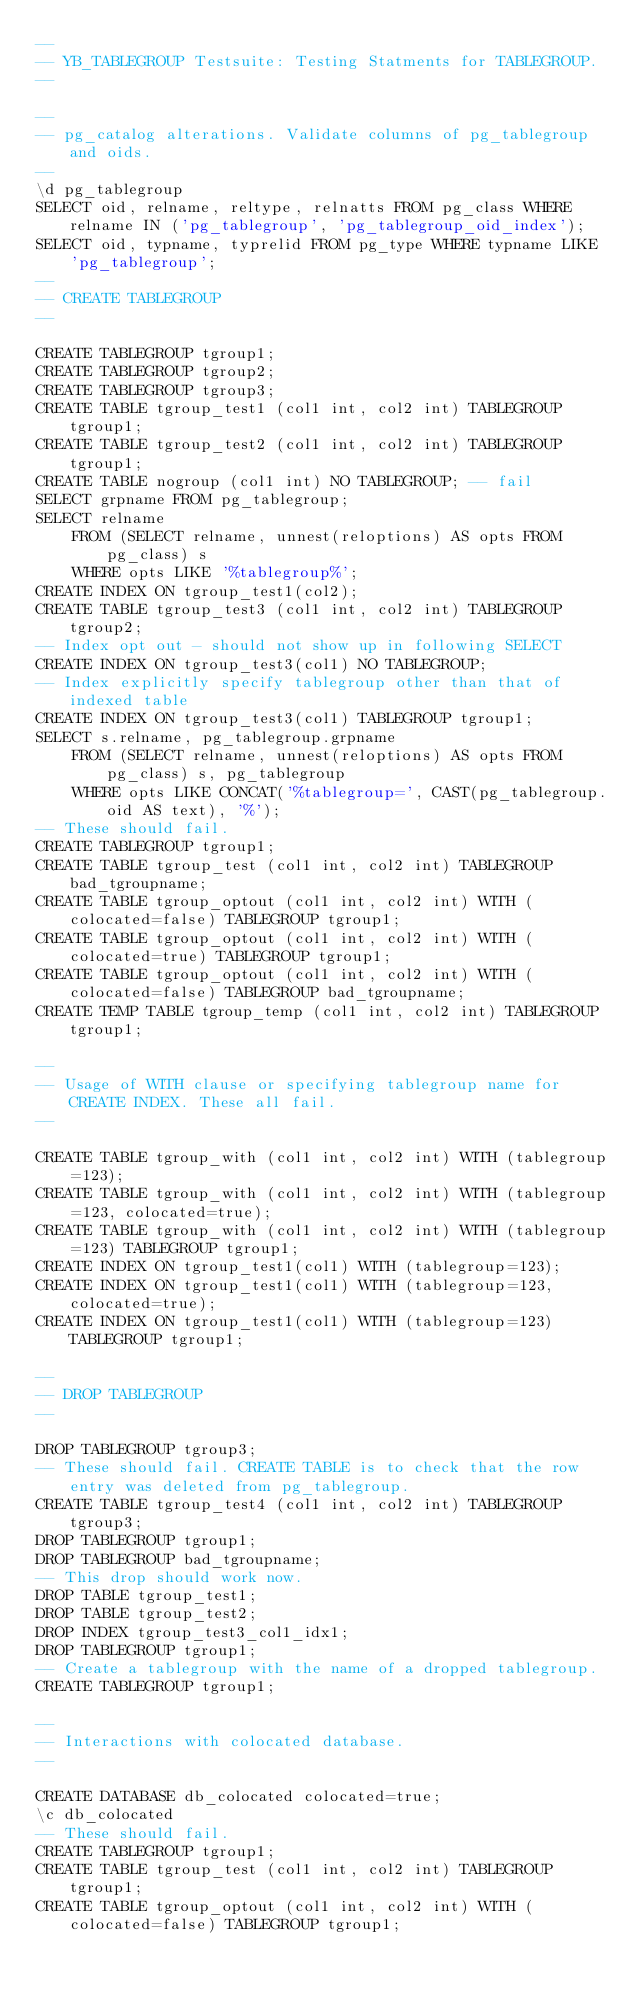Convert code to text. <code><loc_0><loc_0><loc_500><loc_500><_SQL_>--
-- YB_TABLEGROUP Testsuite: Testing Statments for TABLEGROUP.
--

--
-- pg_catalog alterations. Validate columns of pg_tablegroup and oids.
--
\d pg_tablegroup
SELECT oid, relname, reltype, relnatts FROM pg_class WHERE relname IN ('pg_tablegroup', 'pg_tablegroup_oid_index');
SELECT oid, typname, typrelid FROM pg_type WHERE typname LIKE 'pg_tablegroup';
--
-- CREATE TABLEGROUP
--

CREATE TABLEGROUP tgroup1;
CREATE TABLEGROUP tgroup2;
CREATE TABLEGROUP tgroup3;
CREATE TABLE tgroup_test1 (col1 int, col2 int) TABLEGROUP tgroup1;
CREATE TABLE tgroup_test2 (col1 int, col2 int) TABLEGROUP tgroup1;
CREATE TABLE nogroup (col1 int) NO TABLEGROUP; -- fail
SELECT grpname FROM pg_tablegroup;
SELECT relname
    FROM (SELECT relname, unnest(reloptions) AS opts FROM pg_class) s
    WHERE opts LIKE '%tablegroup%';
CREATE INDEX ON tgroup_test1(col2);
CREATE TABLE tgroup_test3 (col1 int, col2 int) TABLEGROUP tgroup2;
-- Index opt out - should not show up in following SELECT
CREATE INDEX ON tgroup_test3(col1) NO TABLEGROUP;
-- Index explicitly specify tablegroup other than that of indexed table
CREATE INDEX ON tgroup_test3(col1) TABLEGROUP tgroup1;
SELECT s.relname, pg_tablegroup.grpname
    FROM (SELECT relname, unnest(reloptions) AS opts FROM pg_class) s, pg_tablegroup
    WHERE opts LIKE CONCAT('%tablegroup=', CAST(pg_tablegroup.oid AS text), '%');
-- These should fail.
CREATE TABLEGROUP tgroup1;
CREATE TABLE tgroup_test (col1 int, col2 int) TABLEGROUP bad_tgroupname;
CREATE TABLE tgroup_optout (col1 int, col2 int) WITH (colocated=false) TABLEGROUP tgroup1;
CREATE TABLE tgroup_optout (col1 int, col2 int) WITH (colocated=true) TABLEGROUP tgroup1;
CREATE TABLE tgroup_optout (col1 int, col2 int) WITH (colocated=false) TABLEGROUP bad_tgroupname;
CREATE TEMP TABLE tgroup_temp (col1 int, col2 int) TABLEGROUP tgroup1;

--
-- Usage of WITH clause or specifying tablegroup name for CREATE INDEX. These all fail.
--

CREATE TABLE tgroup_with (col1 int, col2 int) WITH (tablegroup=123);
CREATE TABLE tgroup_with (col1 int, col2 int) WITH (tablegroup=123, colocated=true);
CREATE TABLE tgroup_with (col1 int, col2 int) WITH (tablegroup=123) TABLEGROUP tgroup1;
CREATE INDEX ON tgroup_test1(col1) WITH (tablegroup=123);
CREATE INDEX ON tgroup_test1(col1) WITH (tablegroup=123, colocated=true);
CREATE INDEX ON tgroup_test1(col1) WITH (tablegroup=123) TABLEGROUP tgroup1;

--
-- DROP TABLEGROUP
--

DROP TABLEGROUP tgroup3;
-- These should fail. CREATE TABLE is to check that the row entry was deleted from pg_tablegroup.
CREATE TABLE tgroup_test4 (col1 int, col2 int) TABLEGROUP tgroup3;
DROP TABLEGROUP tgroup1;
DROP TABLEGROUP bad_tgroupname;
-- This drop should work now.
DROP TABLE tgroup_test1;
DROP TABLE tgroup_test2;
DROP INDEX tgroup_test3_col1_idx1;
DROP TABLEGROUP tgroup1;
-- Create a tablegroup with the name of a dropped tablegroup.
CREATE TABLEGROUP tgroup1;

--
-- Interactions with colocated database.
--

CREATE DATABASE db_colocated colocated=true;
\c db_colocated
-- These should fail.
CREATE TABLEGROUP tgroup1;
CREATE TABLE tgroup_test (col1 int, col2 int) TABLEGROUP tgroup1;
CREATE TABLE tgroup_optout (col1 int, col2 int) WITH (colocated=false) TABLEGROUP tgroup1;
</code> 